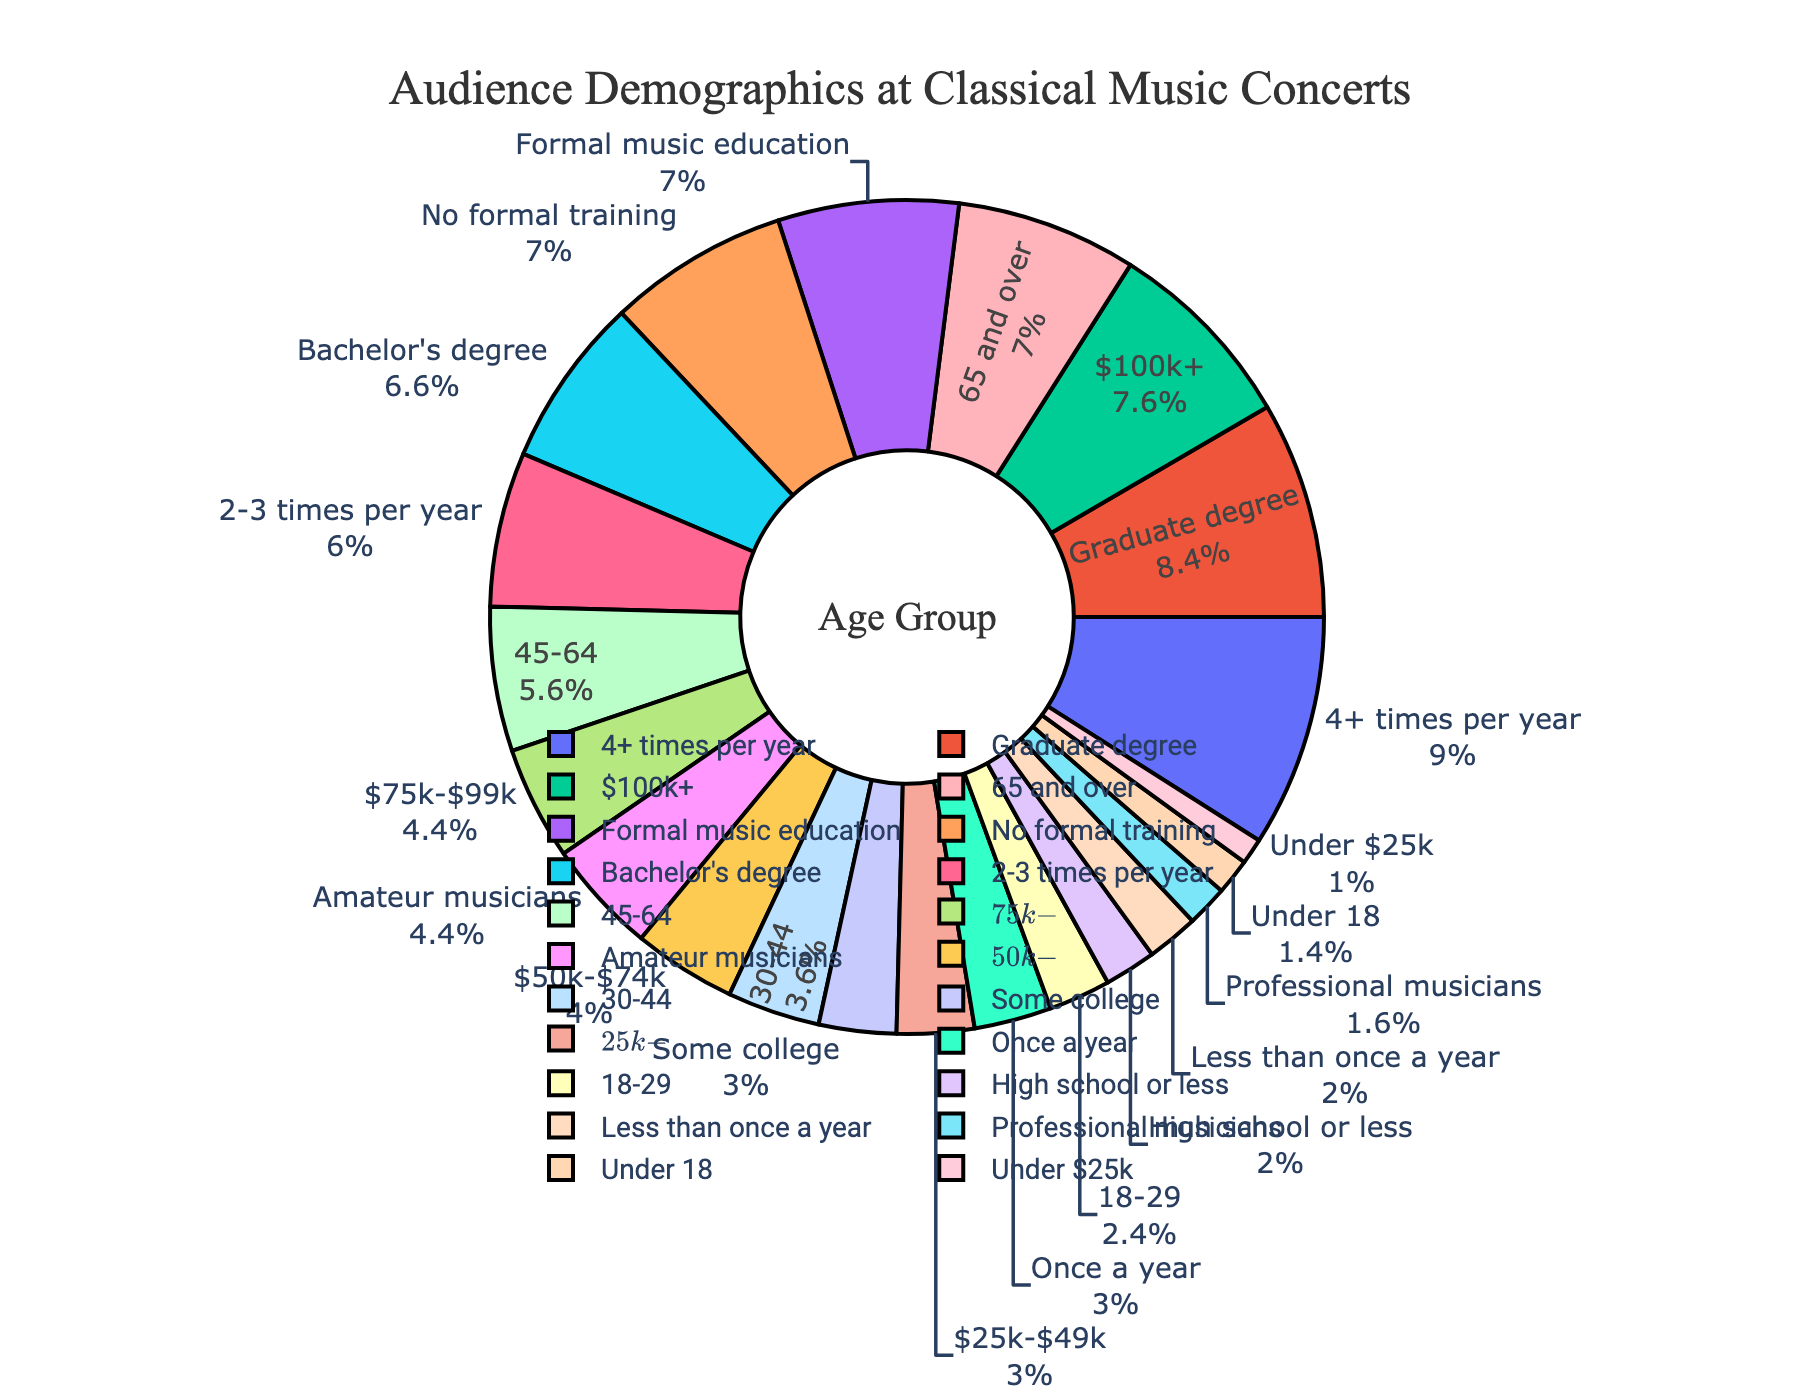Which age group has the largest percentage of attendees? The pie chart visually shows segments with different sizes and percentages. The age group "65 and over" has the largest segment, representing 35% of the attendees.
Answer: 65 and over Which education level has more attendees: "Graduate degree" or "Bachelor's degree"? By comparing the segments in the pie chart, the segment for "Graduate degree" is larger at 42%, whereas "Bachelor's degree" is 33%. Therefore, more attendees have a graduate degree.
Answer: Graduate degree What is the combined percentage of attendees under 45 years old? To find this, we sum the percentages of the age groups "Under 18", "18-29", and "30-44". Thus, 7% + 12% + 18% = 37%.
Answer: 37% Which segment representing income levels is visually the smallest? By observing the pie chart, the smallest segment based on visual size is "Under $25k", representing 5%.
Answer: Under $25k Among those with musical backgrounds, what is the combined percentage of amateur musicians and those with formal music education? Add the percentages of "Amateur musicians" and "Formal music education". Thus, 22% + 35% = 57%.
Answer: 57% Are there more professionals or amateurs in the audience demographics for musical background? The pie chart indicates that 8% are professional musicians while 22% are amateur musicians, thus there are more amateurs.
Answer: Amateurs Which two age groups have the closest percentages of attendees? By comparing the percentages, the age groups "30-44" and "18-29" have 18% and 12% respectively, which are closer compared to other groups.
Answer: 30-44 and 18-29 How much larger is the percentage of attendees who attend 4+ times per year compared to those who attend once a year? Subtract the percentage of "Once a year" (15%) from "4+ times per year" (45%). This gives 45% - 15% = 30%.
Answer: 30% Between the top two education levels, by how much does the percentage of graduate degree holders exceed that of bachelor's degree holders? Subtract the percentage of "Bachelor's degree" (33%) from "Graduate degree" (42%). Thus, 42% - 33% = 9%.
Answer: 9% Out of all age groups, what is the total percentage of attendees 30 years old and above? Add the percentages of "30-44", "45-64", and "65 and over". Thus, 18% + 28% + 35% = 81%.
Answer: 81% 